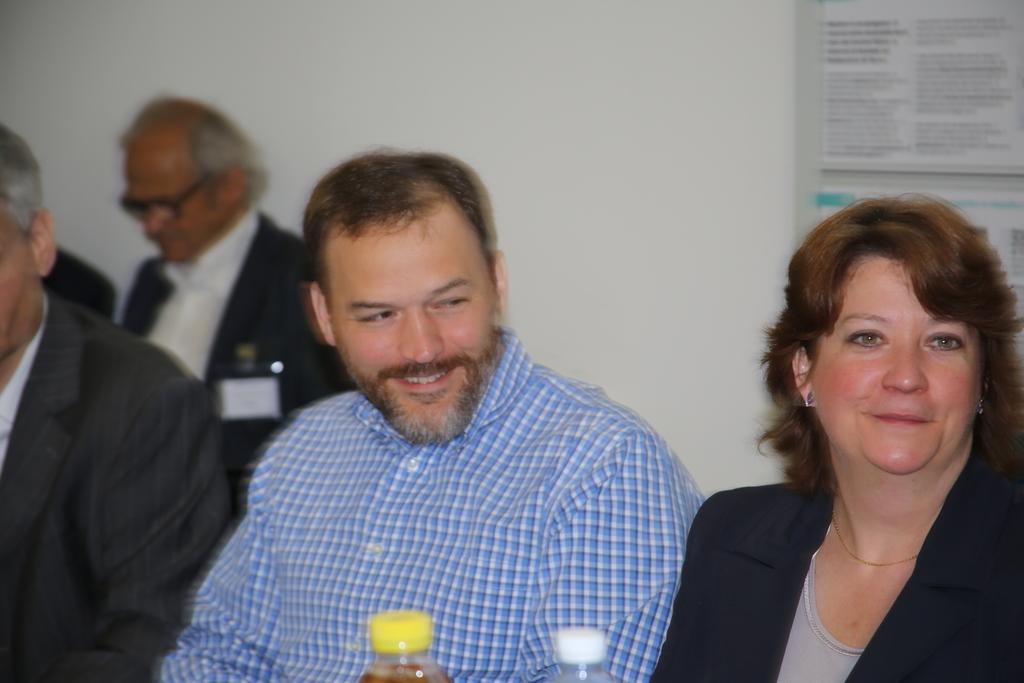Describe this image in one or two sentences. In this image in the front there are persons smiling and there are bottles. In the background there is a frame on the wall with some text written on it and there is a person. 